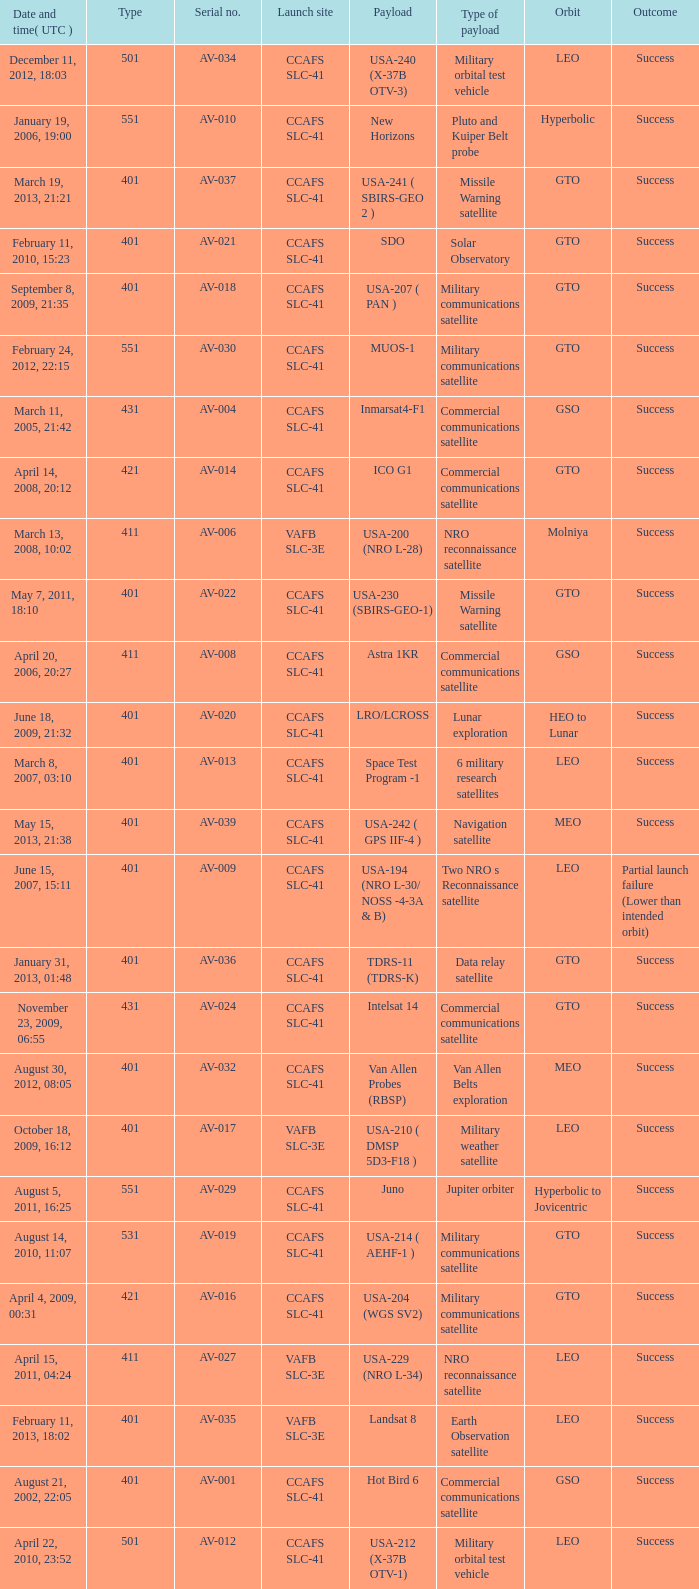When was the payload of Commercial Communications Satellite amc16? December 17, 2004, 12:07. 